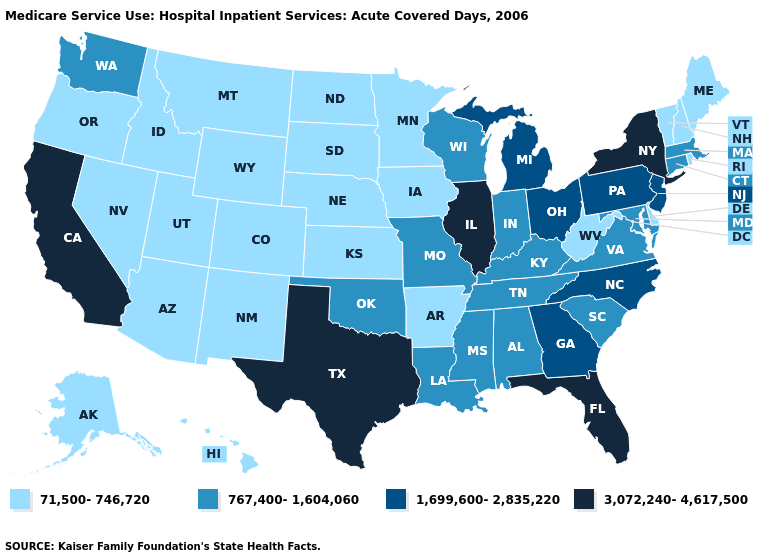Does Mississippi have the lowest value in the USA?
Keep it brief. No. What is the value of Maine?
Answer briefly. 71,500-746,720. What is the highest value in the USA?
Write a very short answer. 3,072,240-4,617,500. What is the value of Michigan?
Keep it brief. 1,699,600-2,835,220. Which states have the highest value in the USA?
Be succinct. California, Florida, Illinois, New York, Texas. What is the value of Idaho?
Answer briefly. 71,500-746,720. Is the legend a continuous bar?
Give a very brief answer. No. Does Illinois have the highest value in the MidWest?
Give a very brief answer. Yes. What is the lowest value in states that border Louisiana?
Give a very brief answer. 71,500-746,720. What is the highest value in the USA?
Write a very short answer. 3,072,240-4,617,500. Which states hav the highest value in the Northeast?
Quick response, please. New York. What is the lowest value in the Northeast?
Answer briefly. 71,500-746,720. Among the states that border New Mexico , which have the lowest value?
Answer briefly. Arizona, Colorado, Utah. What is the highest value in states that border New Mexico?
Short answer required. 3,072,240-4,617,500. 